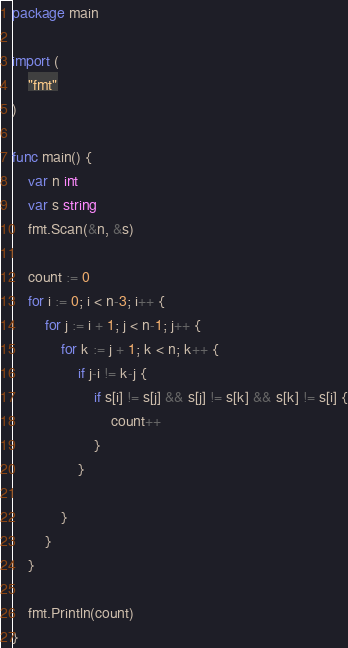<code> <loc_0><loc_0><loc_500><loc_500><_Go_>package main

import (
	"fmt"
)

func main() {
	var n int
	var s string
	fmt.Scan(&n, &s)

	count := 0
	for i := 0; i < n-3; i++ {
		for j := i + 1; j < n-1; j++ {
			for k := j + 1; k < n; k++ {
				if j-i != k-j {
					if s[i] != s[j] && s[j] != s[k] && s[k] != s[i] {
						count++
					}
				}

			}
		}
	}

	fmt.Println(count)
}
</code> 